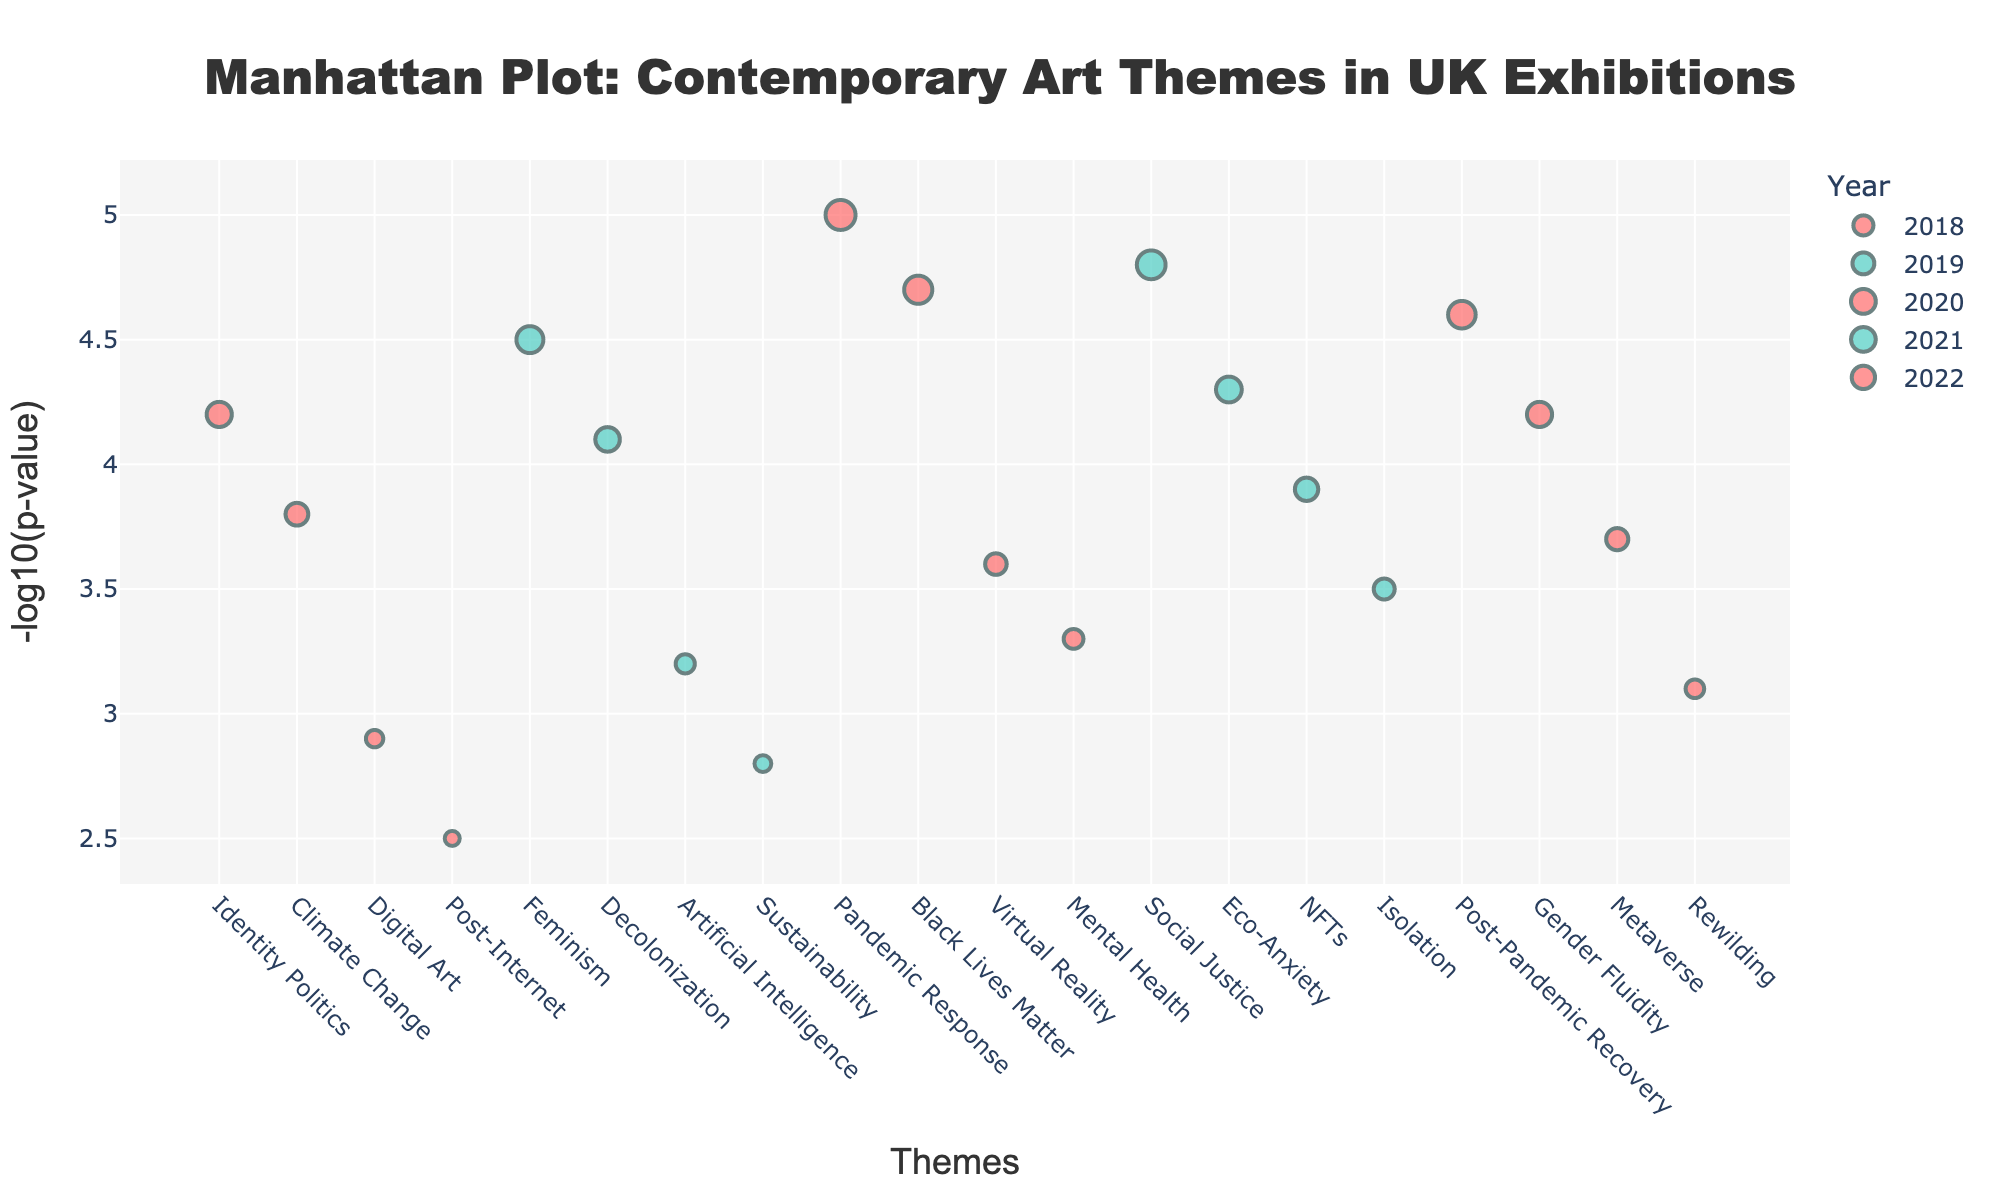What is the title of the figure? The title is usually positioned at the top center of the plot and describes what the figure is about. It reads: "Manhattan Plot: Contemporary Art Themes in UK Exhibitions".
Answer: Manhattan Plot: Contemporary Art Themes in UK Exhibitions What is the y-axis representing? The y-axis is labeled "-log10(p-value)", which indicates that it is measuring the negative log of the p-values of the themes.
Answer: -log10(p-value) How many themes were presented in 2020? From the plot, there are four different data points (markers) that are labeled with the year 2020. These markers are the themes presented in that year.
Answer: 4 Which theme had the highest value in 2021? Analyze the highest point on the y-axis for the year 2021. The theme represented by the highest point in 2021 is "Social Justice" with a Log10P value of 4.8.
Answer: Social Justice Which year had the theme with the highest Log10P value and what was this theme? Identify the highest point on the plot for any year. The highest Log10P value is 5.0 in 2020 with the theme "Pandemic Response".
Answer: 2020, Pandemic Response What is the average Log10P value for the themes in 2019? Sum the Log10P values of themes in 2019 and divide by the number of themes. (4.5 + 4.1 + 3.2 + 2.8) / 4 = 3.65
Answer: 3.65 Compare the Log10P values of "Metaverse" in 2022 and "Virtual Reality" in 2020, which one is higher? Locate the points for "Metaverse" in 2022 and "Virtual Reality" in 2020 on the plot, and compare their Log10P values. "Metaverse" has a Log10P value of 3.7, whereas "Virtual Reality" has a Log10P value of 3.6.
Answer: Metaverse Which two years have the largest difference in the number of themes presented? Count the number of themes (markers) for each year and identify the largest difference in count. The year 2020 had 4 themes, and the year 2018 had 4 themes, resulting in the largest difference being 0.
Answer: No significant difference Which theme in 2022 had the lowest Log10P value? Identify the lowest point on the y-axis for the year 2022. The theme at this point is "Rewilding" with a Log10P value of 3.1.
Answer: Rewilding 